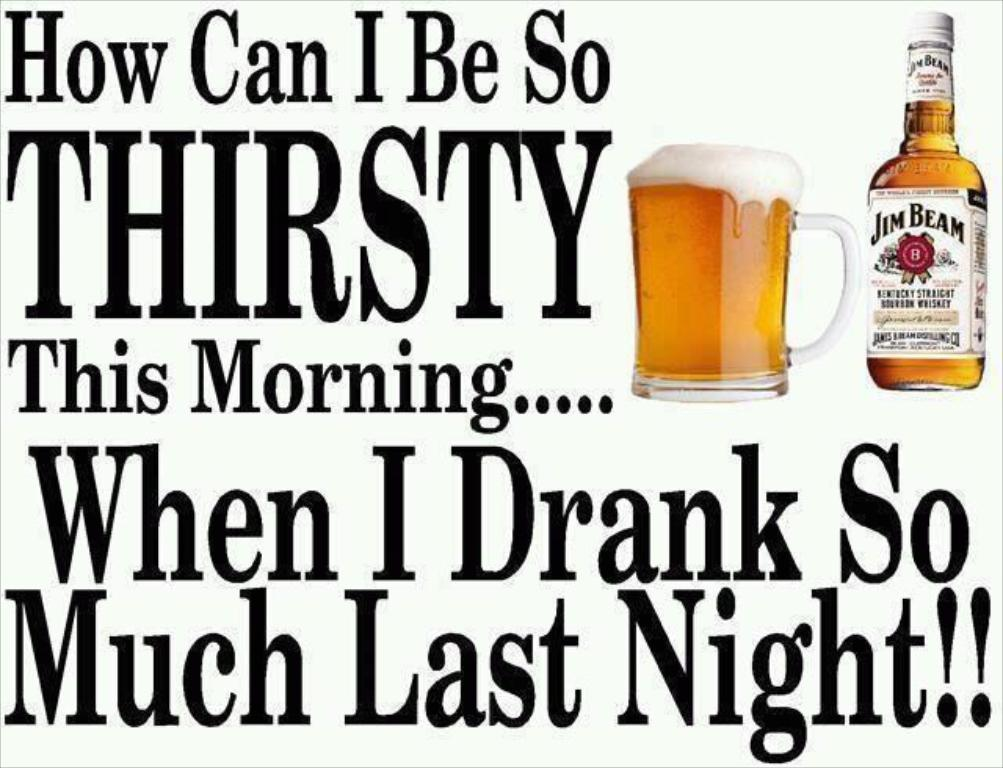<image>
Provide a brief description of the given image. An advertisement for Jim Beam Kentucky straight bourbon whiskey 